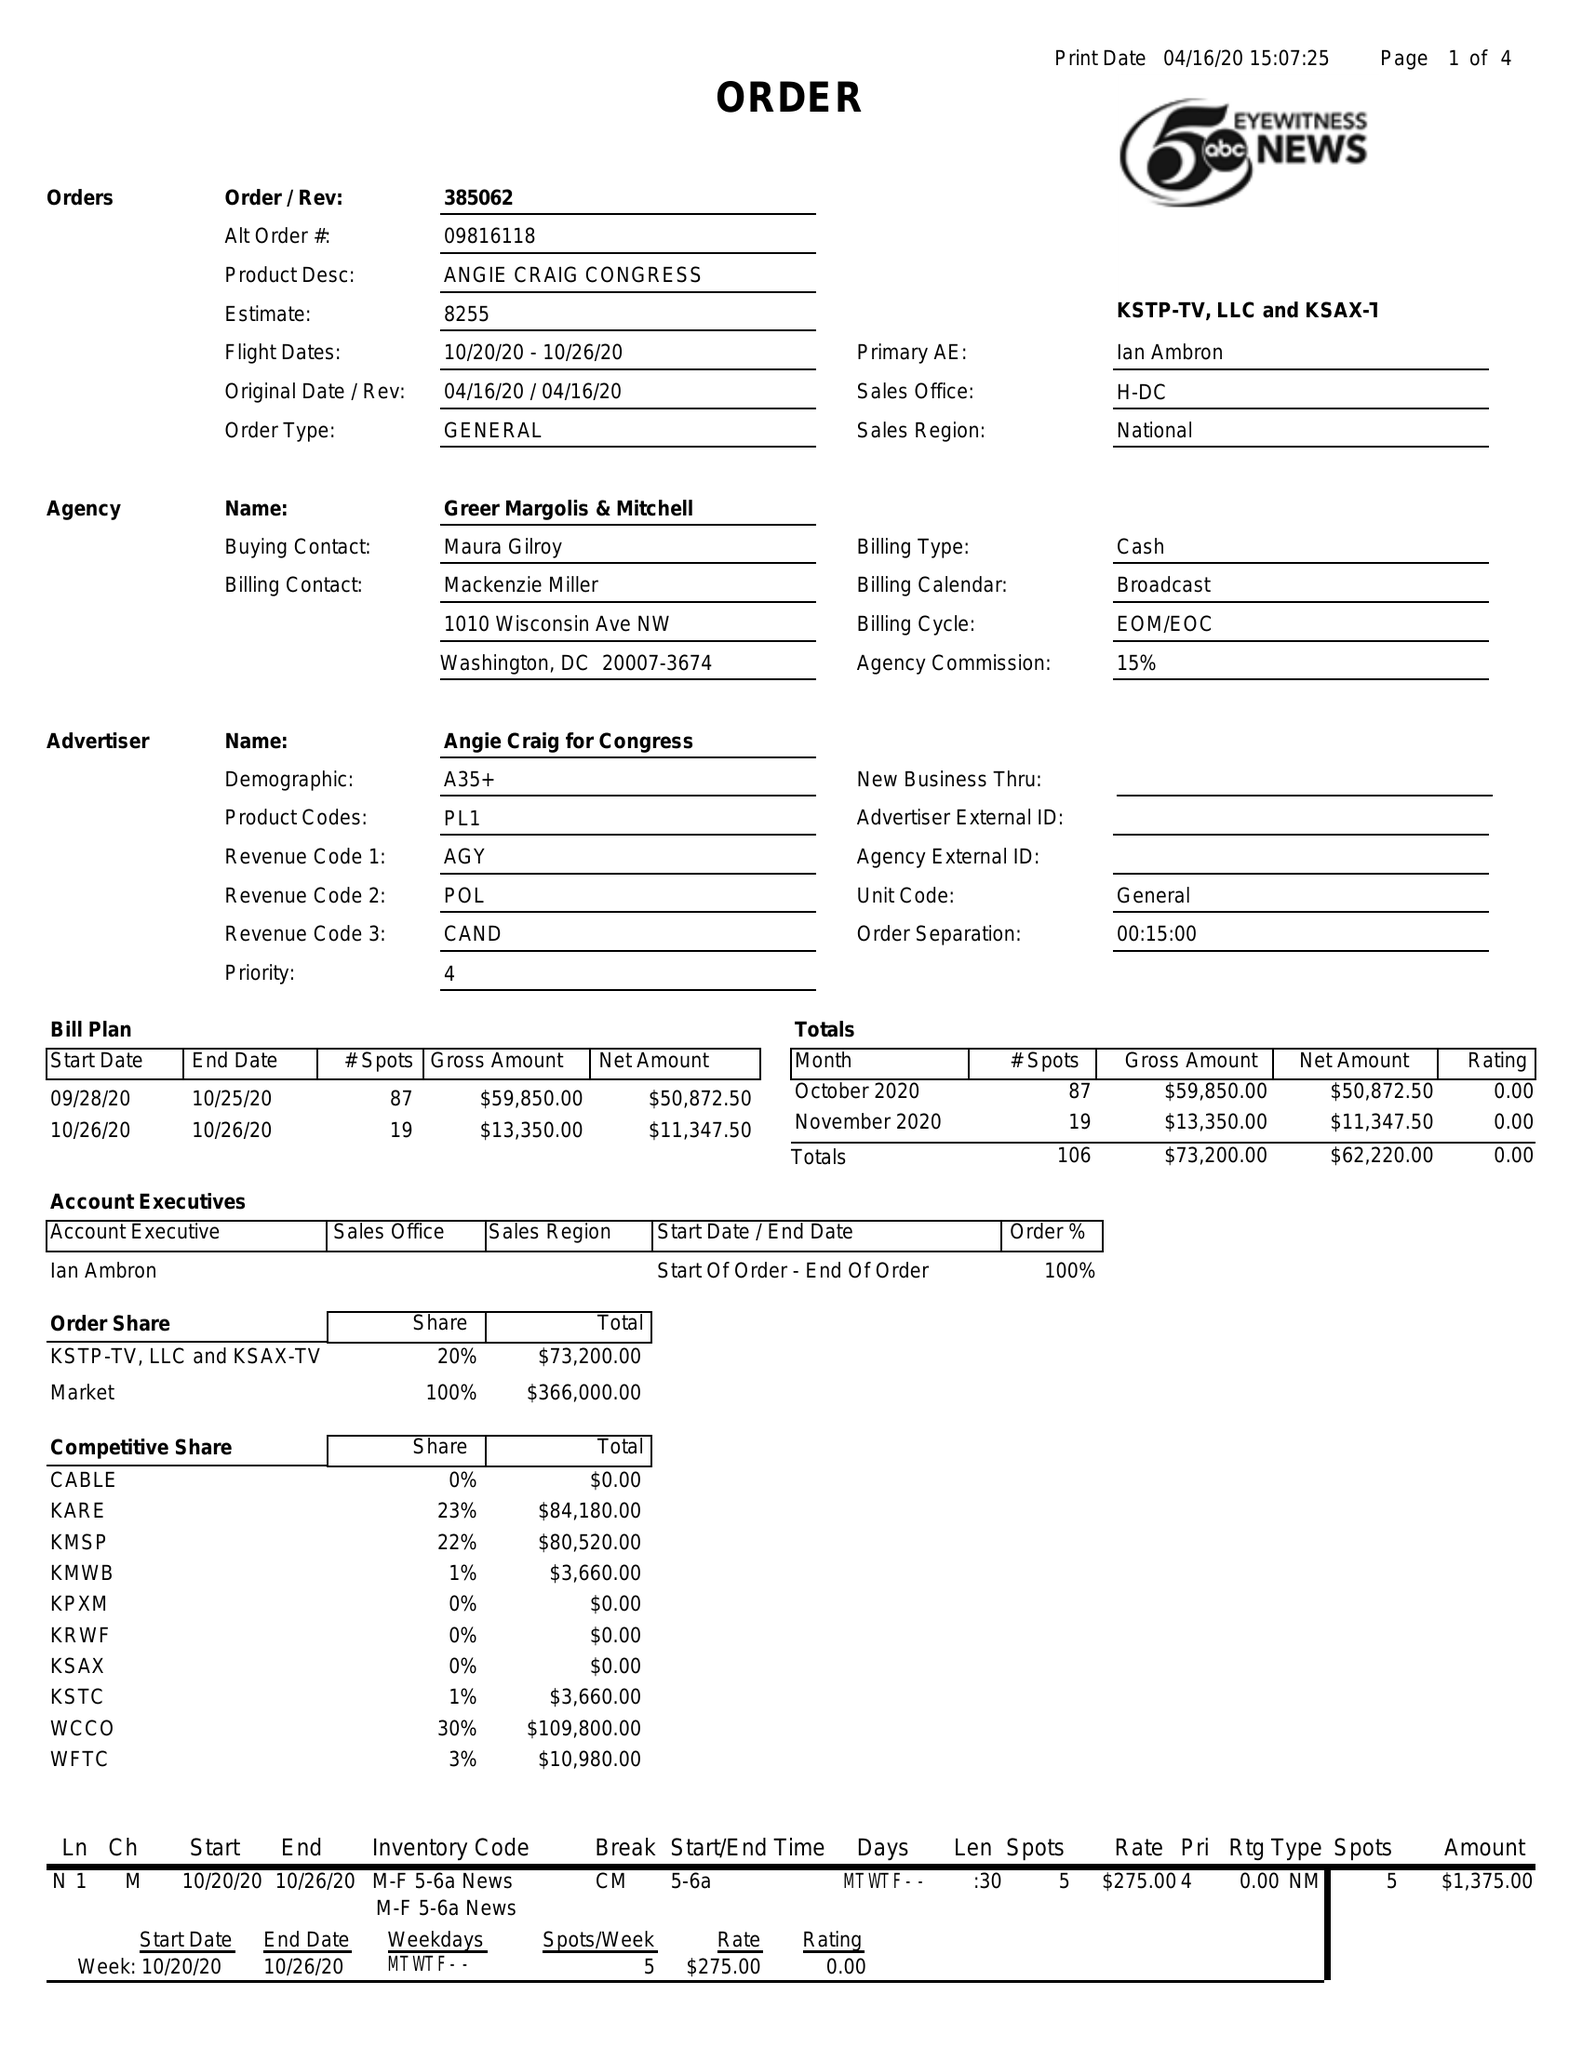What is the value for the advertiser?
Answer the question using a single word or phrase. ANGIE CRAIG FOR CONGRESS 